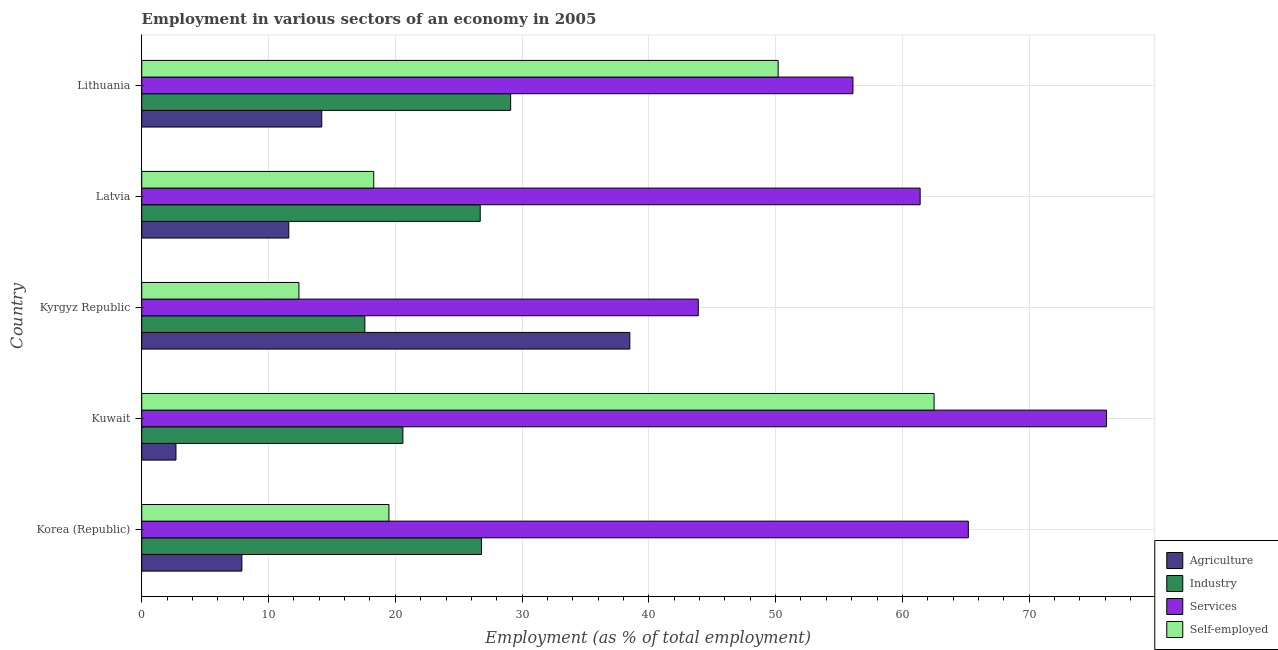How many groups of bars are there?
Provide a short and direct response. 5. Are the number of bars on each tick of the Y-axis equal?
Provide a short and direct response. Yes. What is the label of the 3rd group of bars from the top?
Provide a succinct answer. Kyrgyz Republic. What is the percentage of workers in agriculture in Latvia?
Ensure brevity in your answer.  11.6. Across all countries, what is the maximum percentage of workers in services?
Give a very brief answer. 76.1. Across all countries, what is the minimum percentage of self employed workers?
Your answer should be compact. 12.4. In which country was the percentage of workers in industry maximum?
Your answer should be very brief. Lithuania. In which country was the percentage of workers in industry minimum?
Offer a very short reply. Kyrgyz Republic. What is the total percentage of workers in agriculture in the graph?
Make the answer very short. 74.9. What is the difference between the percentage of workers in industry in Kyrgyz Republic and the percentage of self employed workers in Lithuania?
Offer a terse response. -32.6. What is the average percentage of workers in industry per country?
Provide a short and direct response. 24.16. What is the ratio of the percentage of self employed workers in Korea (Republic) to that in Latvia?
Offer a very short reply. 1.07. What is the difference between the highest and the second highest percentage of workers in agriculture?
Your answer should be compact. 24.3. What is the difference between the highest and the lowest percentage of workers in services?
Offer a terse response. 32.2. Is the sum of the percentage of workers in agriculture in Kyrgyz Republic and Latvia greater than the maximum percentage of workers in services across all countries?
Offer a terse response. No. What does the 2nd bar from the top in Latvia represents?
Make the answer very short. Services. What does the 2nd bar from the bottom in Latvia represents?
Provide a short and direct response. Industry. How many countries are there in the graph?
Keep it short and to the point. 5. What is the difference between two consecutive major ticks on the X-axis?
Make the answer very short. 10. What is the title of the graph?
Make the answer very short. Employment in various sectors of an economy in 2005. What is the label or title of the X-axis?
Ensure brevity in your answer.  Employment (as % of total employment). What is the Employment (as % of total employment) in Agriculture in Korea (Republic)?
Offer a terse response. 7.9. What is the Employment (as % of total employment) of Industry in Korea (Republic)?
Your answer should be compact. 26.8. What is the Employment (as % of total employment) in Services in Korea (Republic)?
Keep it short and to the point. 65.2. What is the Employment (as % of total employment) in Agriculture in Kuwait?
Your response must be concise. 2.7. What is the Employment (as % of total employment) in Industry in Kuwait?
Your answer should be very brief. 20.6. What is the Employment (as % of total employment) of Services in Kuwait?
Offer a terse response. 76.1. What is the Employment (as % of total employment) of Self-employed in Kuwait?
Keep it short and to the point. 62.5. What is the Employment (as % of total employment) of Agriculture in Kyrgyz Republic?
Your answer should be very brief. 38.5. What is the Employment (as % of total employment) of Industry in Kyrgyz Republic?
Offer a terse response. 17.6. What is the Employment (as % of total employment) in Services in Kyrgyz Republic?
Provide a short and direct response. 43.9. What is the Employment (as % of total employment) of Self-employed in Kyrgyz Republic?
Your answer should be very brief. 12.4. What is the Employment (as % of total employment) of Agriculture in Latvia?
Make the answer very short. 11.6. What is the Employment (as % of total employment) of Industry in Latvia?
Provide a succinct answer. 26.7. What is the Employment (as % of total employment) in Services in Latvia?
Ensure brevity in your answer.  61.4. What is the Employment (as % of total employment) in Self-employed in Latvia?
Your answer should be compact. 18.3. What is the Employment (as % of total employment) of Agriculture in Lithuania?
Your response must be concise. 14.2. What is the Employment (as % of total employment) of Industry in Lithuania?
Make the answer very short. 29.1. What is the Employment (as % of total employment) in Services in Lithuania?
Give a very brief answer. 56.1. What is the Employment (as % of total employment) of Self-employed in Lithuania?
Offer a terse response. 50.2. Across all countries, what is the maximum Employment (as % of total employment) of Agriculture?
Ensure brevity in your answer.  38.5. Across all countries, what is the maximum Employment (as % of total employment) in Industry?
Ensure brevity in your answer.  29.1. Across all countries, what is the maximum Employment (as % of total employment) in Services?
Ensure brevity in your answer.  76.1. Across all countries, what is the maximum Employment (as % of total employment) in Self-employed?
Provide a succinct answer. 62.5. Across all countries, what is the minimum Employment (as % of total employment) of Agriculture?
Your answer should be very brief. 2.7. Across all countries, what is the minimum Employment (as % of total employment) in Industry?
Keep it short and to the point. 17.6. Across all countries, what is the minimum Employment (as % of total employment) of Services?
Give a very brief answer. 43.9. Across all countries, what is the minimum Employment (as % of total employment) in Self-employed?
Provide a succinct answer. 12.4. What is the total Employment (as % of total employment) of Agriculture in the graph?
Your answer should be very brief. 74.9. What is the total Employment (as % of total employment) in Industry in the graph?
Provide a succinct answer. 120.8. What is the total Employment (as % of total employment) of Services in the graph?
Offer a terse response. 302.7. What is the total Employment (as % of total employment) of Self-employed in the graph?
Provide a succinct answer. 162.9. What is the difference between the Employment (as % of total employment) in Agriculture in Korea (Republic) and that in Kuwait?
Offer a very short reply. 5.2. What is the difference between the Employment (as % of total employment) in Self-employed in Korea (Republic) and that in Kuwait?
Your response must be concise. -43. What is the difference between the Employment (as % of total employment) of Agriculture in Korea (Republic) and that in Kyrgyz Republic?
Offer a terse response. -30.6. What is the difference between the Employment (as % of total employment) in Industry in Korea (Republic) and that in Kyrgyz Republic?
Keep it short and to the point. 9.2. What is the difference between the Employment (as % of total employment) in Services in Korea (Republic) and that in Kyrgyz Republic?
Your answer should be compact. 21.3. What is the difference between the Employment (as % of total employment) of Industry in Korea (Republic) and that in Latvia?
Offer a terse response. 0.1. What is the difference between the Employment (as % of total employment) of Services in Korea (Republic) and that in Latvia?
Your answer should be compact. 3.8. What is the difference between the Employment (as % of total employment) of Self-employed in Korea (Republic) and that in Lithuania?
Offer a terse response. -30.7. What is the difference between the Employment (as % of total employment) of Agriculture in Kuwait and that in Kyrgyz Republic?
Your answer should be compact. -35.8. What is the difference between the Employment (as % of total employment) in Services in Kuwait and that in Kyrgyz Republic?
Give a very brief answer. 32.2. What is the difference between the Employment (as % of total employment) in Self-employed in Kuwait and that in Kyrgyz Republic?
Give a very brief answer. 50.1. What is the difference between the Employment (as % of total employment) of Services in Kuwait and that in Latvia?
Give a very brief answer. 14.7. What is the difference between the Employment (as % of total employment) of Self-employed in Kuwait and that in Latvia?
Your response must be concise. 44.2. What is the difference between the Employment (as % of total employment) in Agriculture in Kuwait and that in Lithuania?
Your answer should be compact. -11.5. What is the difference between the Employment (as % of total employment) in Industry in Kuwait and that in Lithuania?
Make the answer very short. -8.5. What is the difference between the Employment (as % of total employment) in Services in Kuwait and that in Lithuania?
Provide a succinct answer. 20. What is the difference between the Employment (as % of total employment) of Agriculture in Kyrgyz Republic and that in Latvia?
Your answer should be very brief. 26.9. What is the difference between the Employment (as % of total employment) of Industry in Kyrgyz Republic and that in Latvia?
Give a very brief answer. -9.1. What is the difference between the Employment (as % of total employment) in Services in Kyrgyz Republic and that in Latvia?
Provide a short and direct response. -17.5. What is the difference between the Employment (as % of total employment) of Agriculture in Kyrgyz Republic and that in Lithuania?
Offer a terse response. 24.3. What is the difference between the Employment (as % of total employment) in Self-employed in Kyrgyz Republic and that in Lithuania?
Provide a succinct answer. -37.8. What is the difference between the Employment (as % of total employment) in Industry in Latvia and that in Lithuania?
Keep it short and to the point. -2.4. What is the difference between the Employment (as % of total employment) in Services in Latvia and that in Lithuania?
Your response must be concise. 5.3. What is the difference between the Employment (as % of total employment) of Self-employed in Latvia and that in Lithuania?
Give a very brief answer. -31.9. What is the difference between the Employment (as % of total employment) of Agriculture in Korea (Republic) and the Employment (as % of total employment) of Industry in Kuwait?
Ensure brevity in your answer.  -12.7. What is the difference between the Employment (as % of total employment) of Agriculture in Korea (Republic) and the Employment (as % of total employment) of Services in Kuwait?
Give a very brief answer. -68.2. What is the difference between the Employment (as % of total employment) of Agriculture in Korea (Republic) and the Employment (as % of total employment) of Self-employed in Kuwait?
Provide a succinct answer. -54.6. What is the difference between the Employment (as % of total employment) in Industry in Korea (Republic) and the Employment (as % of total employment) in Services in Kuwait?
Ensure brevity in your answer.  -49.3. What is the difference between the Employment (as % of total employment) of Industry in Korea (Republic) and the Employment (as % of total employment) of Self-employed in Kuwait?
Keep it short and to the point. -35.7. What is the difference between the Employment (as % of total employment) in Services in Korea (Republic) and the Employment (as % of total employment) in Self-employed in Kuwait?
Give a very brief answer. 2.7. What is the difference between the Employment (as % of total employment) in Agriculture in Korea (Republic) and the Employment (as % of total employment) in Services in Kyrgyz Republic?
Give a very brief answer. -36. What is the difference between the Employment (as % of total employment) in Industry in Korea (Republic) and the Employment (as % of total employment) in Services in Kyrgyz Republic?
Make the answer very short. -17.1. What is the difference between the Employment (as % of total employment) in Industry in Korea (Republic) and the Employment (as % of total employment) in Self-employed in Kyrgyz Republic?
Your answer should be very brief. 14.4. What is the difference between the Employment (as % of total employment) in Services in Korea (Republic) and the Employment (as % of total employment) in Self-employed in Kyrgyz Republic?
Make the answer very short. 52.8. What is the difference between the Employment (as % of total employment) in Agriculture in Korea (Republic) and the Employment (as % of total employment) in Industry in Latvia?
Provide a short and direct response. -18.8. What is the difference between the Employment (as % of total employment) in Agriculture in Korea (Republic) and the Employment (as % of total employment) in Services in Latvia?
Ensure brevity in your answer.  -53.5. What is the difference between the Employment (as % of total employment) in Industry in Korea (Republic) and the Employment (as % of total employment) in Services in Latvia?
Make the answer very short. -34.6. What is the difference between the Employment (as % of total employment) in Industry in Korea (Republic) and the Employment (as % of total employment) in Self-employed in Latvia?
Provide a short and direct response. 8.5. What is the difference between the Employment (as % of total employment) in Services in Korea (Republic) and the Employment (as % of total employment) in Self-employed in Latvia?
Offer a terse response. 46.9. What is the difference between the Employment (as % of total employment) in Agriculture in Korea (Republic) and the Employment (as % of total employment) in Industry in Lithuania?
Keep it short and to the point. -21.2. What is the difference between the Employment (as % of total employment) in Agriculture in Korea (Republic) and the Employment (as % of total employment) in Services in Lithuania?
Provide a succinct answer. -48.2. What is the difference between the Employment (as % of total employment) of Agriculture in Korea (Republic) and the Employment (as % of total employment) of Self-employed in Lithuania?
Offer a very short reply. -42.3. What is the difference between the Employment (as % of total employment) of Industry in Korea (Republic) and the Employment (as % of total employment) of Services in Lithuania?
Ensure brevity in your answer.  -29.3. What is the difference between the Employment (as % of total employment) of Industry in Korea (Republic) and the Employment (as % of total employment) of Self-employed in Lithuania?
Keep it short and to the point. -23.4. What is the difference between the Employment (as % of total employment) of Services in Korea (Republic) and the Employment (as % of total employment) of Self-employed in Lithuania?
Make the answer very short. 15. What is the difference between the Employment (as % of total employment) in Agriculture in Kuwait and the Employment (as % of total employment) in Industry in Kyrgyz Republic?
Your response must be concise. -14.9. What is the difference between the Employment (as % of total employment) in Agriculture in Kuwait and the Employment (as % of total employment) in Services in Kyrgyz Republic?
Offer a very short reply. -41.2. What is the difference between the Employment (as % of total employment) in Agriculture in Kuwait and the Employment (as % of total employment) in Self-employed in Kyrgyz Republic?
Offer a very short reply. -9.7. What is the difference between the Employment (as % of total employment) in Industry in Kuwait and the Employment (as % of total employment) in Services in Kyrgyz Republic?
Provide a short and direct response. -23.3. What is the difference between the Employment (as % of total employment) of Services in Kuwait and the Employment (as % of total employment) of Self-employed in Kyrgyz Republic?
Your answer should be very brief. 63.7. What is the difference between the Employment (as % of total employment) in Agriculture in Kuwait and the Employment (as % of total employment) in Services in Latvia?
Give a very brief answer. -58.7. What is the difference between the Employment (as % of total employment) of Agriculture in Kuwait and the Employment (as % of total employment) of Self-employed in Latvia?
Provide a succinct answer. -15.6. What is the difference between the Employment (as % of total employment) in Industry in Kuwait and the Employment (as % of total employment) in Services in Latvia?
Ensure brevity in your answer.  -40.8. What is the difference between the Employment (as % of total employment) in Services in Kuwait and the Employment (as % of total employment) in Self-employed in Latvia?
Offer a very short reply. 57.8. What is the difference between the Employment (as % of total employment) in Agriculture in Kuwait and the Employment (as % of total employment) in Industry in Lithuania?
Offer a terse response. -26.4. What is the difference between the Employment (as % of total employment) in Agriculture in Kuwait and the Employment (as % of total employment) in Services in Lithuania?
Your answer should be very brief. -53.4. What is the difference between the Employment (as % of total employment) in Agriculture in Kuwait and the Employment (as % of total employment) in Self-employed in Lithuania?
Give a very brief answer. -47.5. What is the difference between the Employment (as % of total employment) of Industry in Kuwait and the Employment (as % of total employment) of Services in Lithuania?
Offer a very short reply. -35.5. What is the difference between the Employment (as % of total employment) in Industry in Kuwait and the Employment (as % of total employment) in Self-employed in Lithuania?
Your answer should be compact. -29.6. What is the difference between the Employment (as % of total employment) in Services in Kuwait and the Employment (as % of total employment) in Self-employed in Lithuania?
Your answer should be very brief. 25.9. What is the difference between the Employment (as % of total employment) in Agriculture in Kyrgyz Republic and the Employment (as % of total employment) in Services in Latvia?
Offer a very short reply. -22.9. What is the difference between the Employment (as % of total employment) of Agriculture in Kyrgyz Republic and the Employment (as % of total employment) of Self-employed in Latvia?
Your answer should be compact. 20.2. What is the difference between the Employment (as % of total employment) in Industry in Kyrgyz Republic and the Employment (as % of total employment) in Services in Latvia?
Your answer should be very brief. -43.8. What is the difference between the Employment (as % of total employment) in Services in Kyrgyz Republic and the Employment (as % of total employment) in Self-employed in Latvia?
Your response must be concise. 25.6. What is the difference between the Employment (as % of total employment) in Agriculture in Kyrgyz Republic and the Employment (as % of total employment) in Services in Lithuania?
Keep it short and to the point. -17.6. What is the difference between the Employment (as % of total employment) in Industry in Kyrgyz Republic and the Employment (as % of total employment) in Services in Lithuania?
Offer a terse response. -38.5. What is the difference between the Employment (as % of total employment) of Industry in Kyrgyz Republic and the Employment (as % of total employment) of Self-employed in Lithuania?
Your response must be concise. -32.6. What is the difference between the Employment (as % of total employment) in Services in Kyrgyz Republic and the Employment (as % of total employment) in Self-employed in Lithuania?
Your answer should be compact. -6.3. What is the difference between the Employment (as % of total employment) in Agriculture in Latvia and the Employment (as % of total employment) in Industry in Lithuania?
Your answer should be compact. -17.5. What is the difference between the Employment (as % of total employment) of Agriculture in Latvia and the Employment (as % of total employment) of Services in Lithuania?
Your answer should be compact. -44.5. What is the difference between the Employment (as % of total employment) in Agriculture in Latvia and the Employment (as % of total employment) in Self-employed in Lithuania?
Keep it short and to the point. -38.6. What is the difference between the Employment (as % of total employment) in Industry in Latvia and the Employment (as % of total employment) in Services in Lithuania?
Provide a short and direct response. -29.4. What is the difference between the Employment (as % of total employment) in Industry in Latvia and the Employment (as % of total employment) in Self-employed in Lithuania?
Offer a very short reply. -23.5. What is the difference between the Employment (as % of total employment) in Services in Latvia and the Employment (as % of total employment) in Self-employed in Lithuania?
Offer a terse response. 11.2. What is the average Employment (as % of total employment) of Agriculture per country?
Provide a succinct answer. 14.98. What is the average Employment (as % of total employment) in Industry per country?
Offer a very short reply. 24.16. What is the average Employment (as % of total employment) in Services per country?
Give a very brief answer. 60.54. What is the average Employment (as % of total employment) of Self-employed per country?
Make the answer very short. 32.58. What is the difference between the Employment (as % of total employment) of Agriculture and Employment (as % of total employment) of Industry in Korea (Republic)?
Ensure brevity in your answer.  -18.9. What is the difference between the Employment (as % of total employment) of Agriculture and Employment (as % of total employment) of Services in Korea (Republic)?
Provide a short and direct response. -57.3. What is the difference between the Employment (as % of total employment) of Industry and Employment (as % of total employment) of Services in Korea (Republic)?
Offer a very short reply. -38.4. What is the difference between the Employment (as % of total employment) of Services and Employment (as % of total employment) of Self-employed in Korea (Republic)?
Give a very brief answer. 45.7. What is the difference between the Employment (as % of total employment) of Agriculture and Employment (as % of total employment) of Industry in Kuwait?
Ensure brevity in your answer.  -17.9. What is the difference between the Employment (as % of total employment) of Agriculture and Employment (as % of total employment) of Services in Kuwait?
Your answer should be compact. -73.4. What is the difference between the Employment (as % of total employment) in Agriculture and Employment (as % of total employment) in Self-employed in Kuwait?
Offer a very short reply. -59.8. What is the difference between the Employment (as % of total employment) in Industry and Employment (as % of total employment) in Services in Kuwait?
Give a very brief answer. -55.5. What is the difference between the Employment (as % of total employment) in Industry and Employment (as % of total employment) in Self-employed in Kuwait?
Offer a very short reply. -41.9. What is the difference between the Employment (as % of total employment) in Services and Employment (as % of total employment) in Self-employed in Kuwait?
Provide a short and direct response. 13.6. What is the difference between the Employment (as % of total employment) in Agriculture and Employment (as % of total employment) in Industry in Kyrgyz Republic?
Provide a succinct answer. 20.9. What is the difference between the Employment (as % of total employment) of Agriculture and Employment (as % of total employment) of Self-employed in Kyrgyz Republic?
Make the answer very short. 26.1. What is the difference between the Employment (as % of total employment) of Industry and Employment (as % of total employment) of Services in Kyrgyz Republic?
Provide a short and direct response. -26.3. What is the difference between the Employment (as % of total employment) of Services and Employment (as % of total employment) of Self-employed in Kyrgyz Republic?
Make the answer very short. 31.5. What is the difference between the Employment (as % of total employment) of Agriculture and Employment (as % of total employment) of Industry in Latvia?
Offer a terse response. -15.1. What is the difference between the Employment (as % of total employment) in Agriculture and Employment (as % of total employment) in Services in Latvia?
Provide a short and direct response. -49.8. What is the difference between the Employment (as % of total employment) of Industry and Employment (as % of total employment) of Services in Latvia?
Offer a terse response. -34.7. What is the difference between the Employment (as % of total employment) of Industry and Employment (as % of total employment) of Self-employed in Latvia?
Your answer should be compact. 8.4. What is the difference between the Employment (as % of total employment) in Services and Employment (as % of total employment) in Self-employed in Latvia?
Keep it short and to the point. 43.1. What is the difference between the Employment (as % of total employment) of Agriculture and Employment (as % of total employment) of Industry in Lithuania?
Offer a very short reply. -14.9. What is the difference between the Employment (as % of total employment) in Agriculture and Employment (as % of total employment) in Services in Lithuania?
Give a very brief answer. -41.9. What is the difference between the Employment (as % of total employment) of Agriculture and Employment (as % of total employment) of Self-employed in Lithuania?
Offer a very short reply. -36. What is the difference between the Employment (as % of total employment) of Industry and Employment (as % of total employment) of Services in Lithuania?
Offer a very short reply. -27. What is the difference between the Employment (as % of total employment) of Industry and Employment (as % of total employment) of Self-employed in Lithuania?
Offer a very short reply. -21.1. What is the ratio of the Employment (as % of total employment) of Agriculture in Korea (Republic) to that in Kuwait?
Provide a short and direct response. 2.93. What is the ratio of the Employment (as % of total employment) in Industry in Korea (Republic) to that in Kuwait?
Ensure brevity in your answer.  1.3. What is the ratio of the Employment (as % of total employment) of Services in Korea (Republic) to that in Kuwait?
Your response must be concise. 0.86. What is the ratio of the Employment (as % of total employment) of Self-employed in Korea (Republic) to that in Kuwait?
Keep it short and to the point. 0.31. What is the ratio of the Employment (as % of total employment) in Agriculture in Korea (Republic) to that in Kyrgyz Republic?
Offer a terse response. 0.21. What is the ratio of the Employment (as % of total employment) in Industry in Korea (Republic) to that in Kyrgyz Republic?
Keep it short and to the point. 1.52. What is the ratio of the Employment (as % of total employment) of Services in Korea (Republic) to that in Kyrgyz Republic?
Give a very brief answer. 1.49. What is the ratio of the Employment (as % of total employment) in Self-employed in Korea (Republic) to that in Kyrgyz Republic?
Give a very brief answer. 1.57. What is the ratio of the Employment (as % of total employment) of Agriculture in Korea (Republic) to that in Latvia?
Offer a terse response. 0.68. What is the ratio of the Employment (as % of total employment) in Industry in Korea (Republic) to that in Latvia?
Ensure brevity in your answer.  1. What is the ratio of the Employment (as % of total employment) of Services in Korea (Republic) to that in Latvia?
Give a very brief answer. 1.06. What is the ratio of the Employment (as % of total employment) in Self-employed in Korea (Republic) to that in Latvia?
Offer a very short reply. 1.07. What is the ratio of the Employment (as % of total employment) in Agriculture in Korea (Republic) to that in Lithuania?
Ensure brevity in your answer.  0.56. What is the ratio of the Employment (as % of total employment) of Industry in Korea (Republic) to that in Lithuania?
Provide a succinct answer. 0.92. What is the ratio of the Employment (as % of total employment) of Services in Korea (Republic) to that in Lithuania?
Provide a short and direct response. 1.16. What is the ratio of the Employment (as % of total employment) of Self-employed in Korea (Republic) to that in Lithuania?
Provide a short and direct response. 0.39. What is the ratio of the Employment (as % of total employment) in Agriculture in Kuwait to that in Kyrgyz Republic?
Give a very brief answer. 0.07. What is the ratio of the Employment (as % of total employment) in Industry in Kuwait to that in Kyrgyz Republic?
Make the answer very short. 1.17. What is the ratio of the Employment (as % of total employment) in Services in Kuwait to that in Kyrgyz Republic?
Give a very brief answer. 1.73. What is the ratio of the Employment (as % of total employment) in Self-employed in Kuwait to that in Kyrgyz Republic?
Give a very brief answer. 5.04. What is the ratio of the Employment (as % of total employment) of Agriculture in Kuwait to that in Latvia?
Offer a terse response. 0.23. What is the ratio of the Employment (as % of total employment) of Industry in Kuwait to that in Latvia?
Your response must be concise. 0.77. What is the ratio of the Employment (as % of total employment) in Services in Kuwait to that in Latvia?
Your response must be concise. 1.24. What is the ratio of the Employment (as % of total employment) of Self-employed in Kuwait to that in Latvia?
Ensure brevity in your answer.  3.42. What is the ratio of the Employment (as % of total employment) in Agriculture in Kuwait to that in Lithuania?
Keep it short and to the point. 0.19. What is the ratio of the Employment (as % of total employment) in Industry in Kuwait to that in Lithuania?
Provide a short and direct response. 0.71. What is the ratio of the Employment (as % of total employment) in Services in Kuwait to that in Lithuania?
Ensure brevity in your answer.  1.36. What is the ratio of the Employment (as % of total employment) in Self-employed in Kuwait to that in Lithuania?
Offer a very short reply. 1.25. What is the ratio of the Employment (as % of total employment) of Agriculture in Kyrgyz Republic to that in Latvia?
Keep it short and to the point. 3.32. What is the ratio of the Employment (as % of total employment) of Industry in Kyrgyz Republic to that in Latvia?
Ensure brevity in your answer.  0.66. What is the ratio of the Employment (as % of total employment) in Services in Kyrgyz Republic to that in Latvia?
Keep it short and to the point. 0.71. What is the ratio of the Employment (as % of total employment) in Self-employed in Kyrgyz Republic to that in Latvia?
Your answer should be compact. 0.68. What is the ratio of the Employment (as % of total employment) of Agriculture in Kyrgyz Republic to that in Lithuania?
Offer a terse response. 2.71. What is the ratio of the Employment (as % of total employment) in Industry in Kyrgyz Republic to that in Lithuania?
Keep it short and to the point. 0.6. What is the ratio of the Employment (as % of total employment) of Services in Kyrgyz Republic to that in Lithuania?
Ensure brevity in your answer.  0.78. What is the ratio of the Employment (as % of total employment) in Self-employed in Kyrgyz Republic to that in Lithuania?
Give a very brief answer. 0.25. What is the ratio of the Employment (as % of total employment) in Agriculture in Latvia to that in Lithuania?
Your response must be concise. 0.82. What is the ratio of the Employment (as % of total employment) of Industry in Latvia to that in Lithuania?
Keep it short and to the point. 0.92. What is the ratio of the Employment (as % of total employment) in Services in Latvia to that in Lithuania?
Offer a very short reply. 1.09. What is the ratio of the Employment (as % of total employment) in Self-employed in Latvia to that in Lithuania?
Your answer should be compact. 0.36. What is the difference between the highest and the second highest Employment (as % of total employment) of Agriculture?
Make the answer very short. 24.3. What is the difference between the highest and the second highest Employment (as % of total employment) in Industry?
Your answer should be very brief. 2.3. What is the difference between the highest and the second highest Employment (as % of total employment) in Self-employed?
Your answer should be compact. 12.3. What is the difference between the highest and the lowest Employment (as % of total employment) in Agriculture?
Offer a very short reply. 35.8. What is the difference between the highest and the lowest Employment (as % of total employment) of Services?
Provide a short and direct response. 32.2. What is the difference between the highest and the lowest Employment (as % of total employment) of Self-employed?
Offer a very short reply. 50.1. 